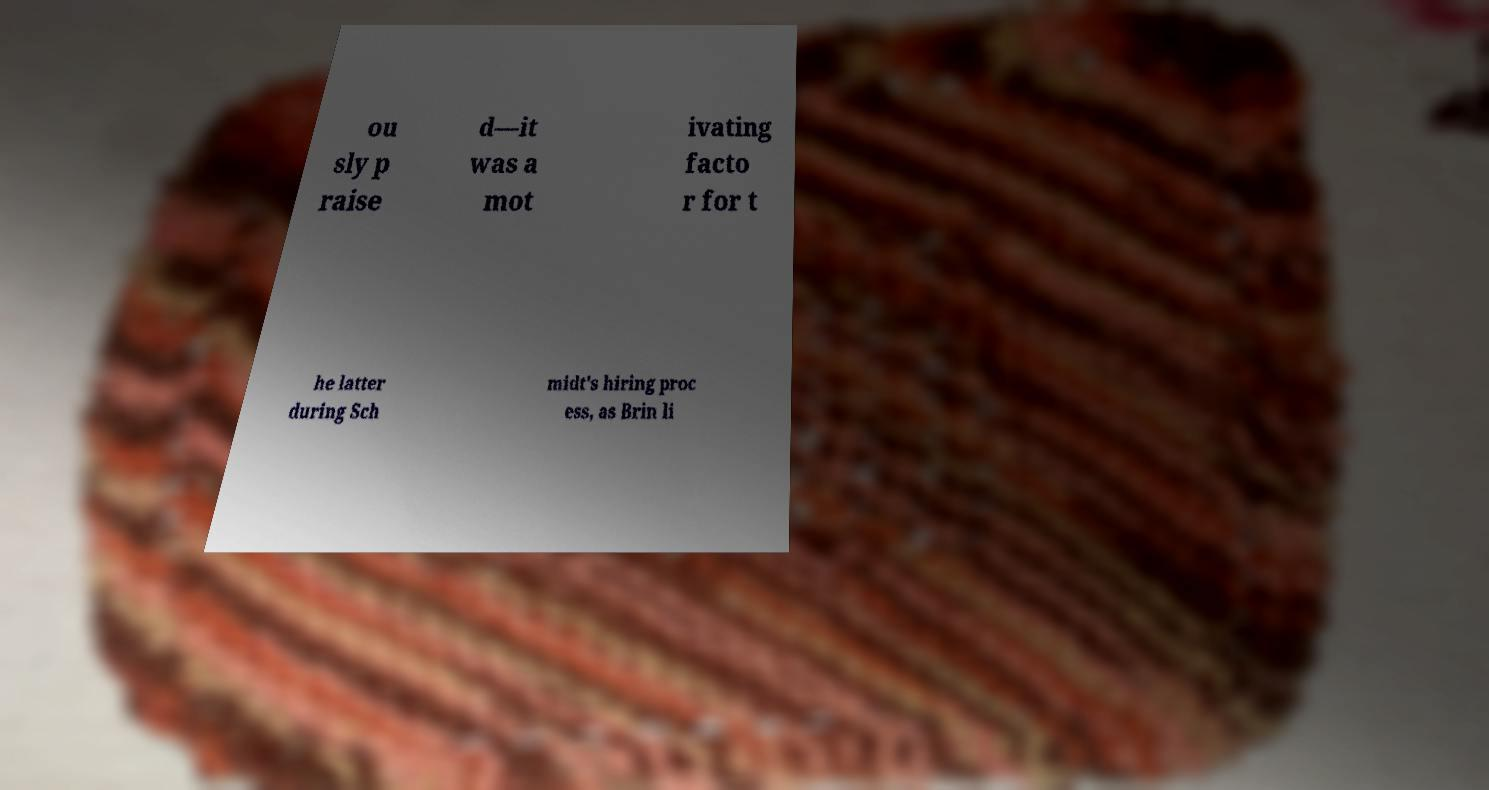Could you assist in decoding the text presented in this image and type it out clearly? ou sly p raise d—it was a mot ivating facto r for t he latter during Sch midt's hiring proc ess, as Brin li 